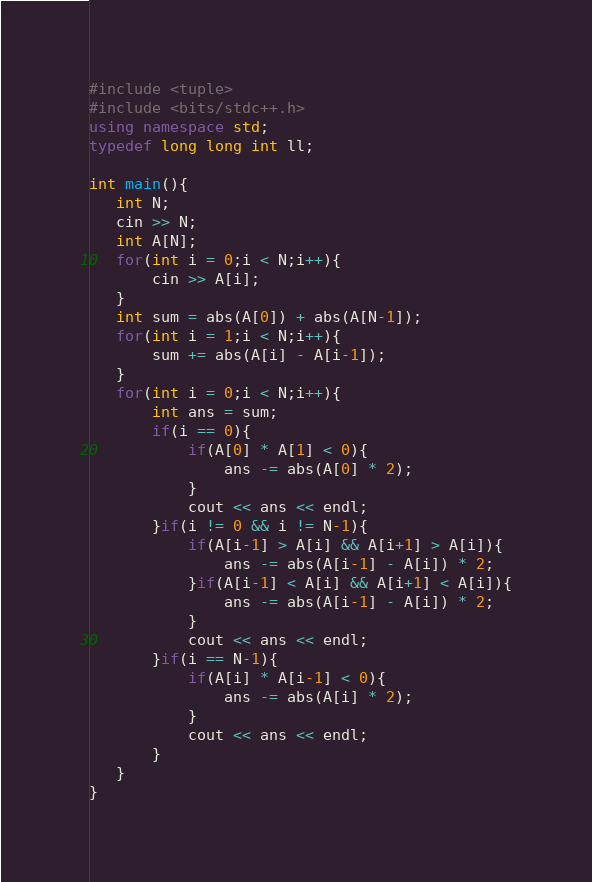<code> <loc_0><loc_0><loc_500><loc_500><_C++_>#include <tuple>
#include <bits/stdc++.h>
using namespace std;
typedef long long int ll;

int main(){
   int N;
   cin >> N;
   int A[N];
   for(int i = 0;i < N;i++){
       cin >> A[i];
   }
   int sum = abs(A[0]) + abs(A[N-1]);
   for(int i = 1;i < N;i++){
       sum += abs(A[i] - A[i-1]);
   }
   for(int i = 0;i < N;i++){
       int ans = sum;
       if(i == 0){
           if(A[0] * A[1] < 0){
               ans -= abs(A[0] * 2);
           }
           cout << ans << endl;
       }if(i != 0 && i != N-1){
           if(A[i-1] > A[i] && A[i+1] > A[i]){
               ans -= abs(A[i-1] - A[i]) * 2;
           }if(A[i-1] < A[i] && A[i+1] < A[i]){
               ans -= abs(A[i-1] - A[i]) * 2;
           }
           cout << ans << endl;
       }if(i == N-1){
           if(A[i] * A[i-1] < 0){
               ans -= abs(A[i] * 2);
           }
           cout << ans << endl;
       }
   }
}</code> 